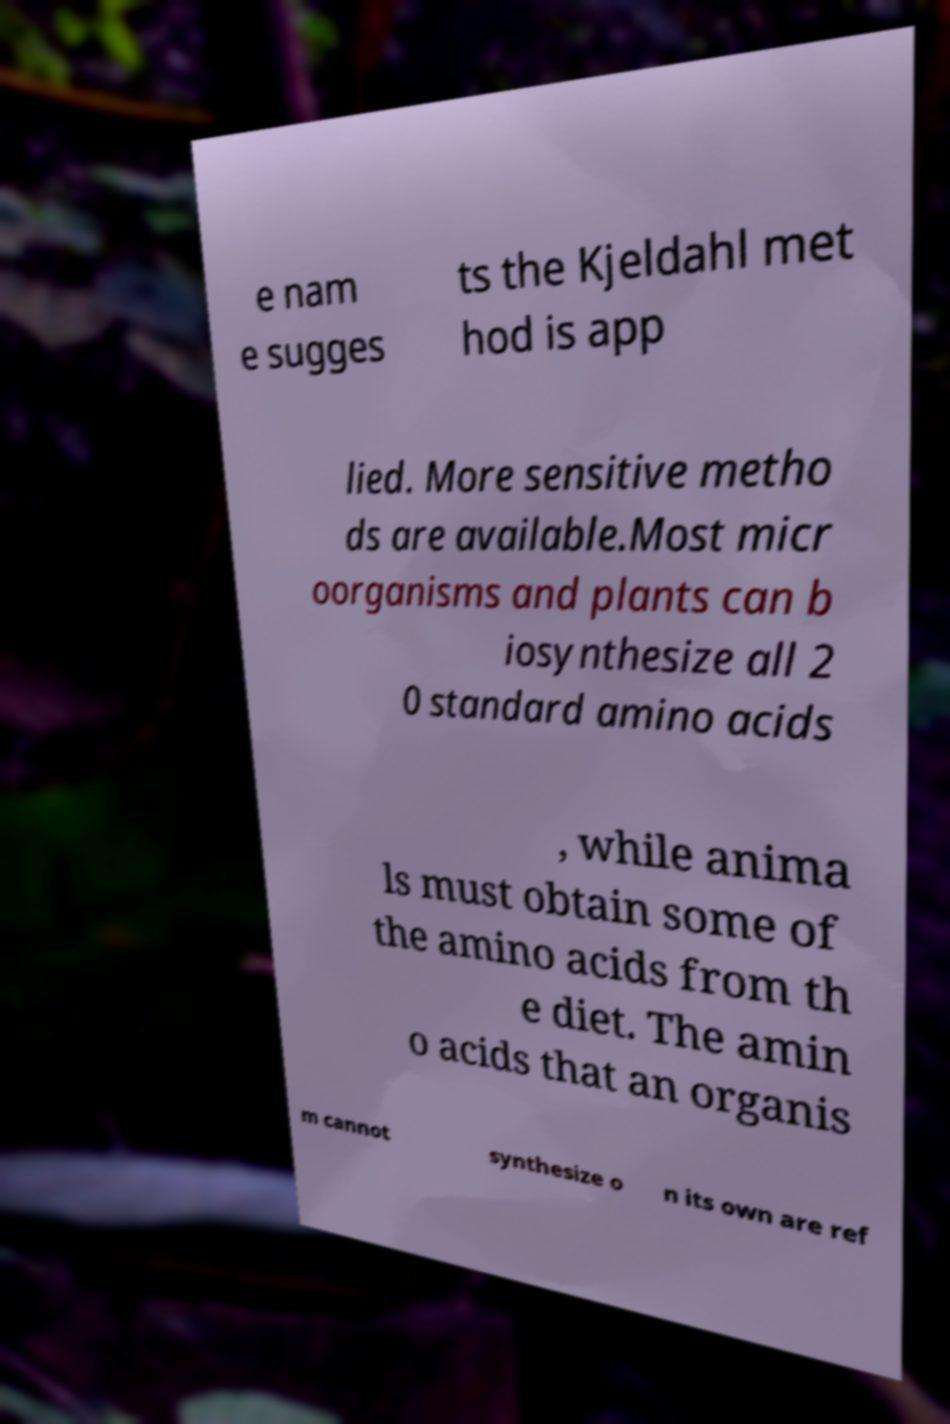I need the written content from this picture converted into text. Can you do that? e nam e sugges ts the Kjeldahl met hod is app lied. More sensitive metho ds are available.Most micr oorganisms and plants can b iosynthesize all 2 0 standard amino acids , while anima ls must obtain some of the amino acids from th e diet. The amin o acids that an organis m cannot synthesize o n its own are ref 